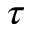<formula> <loc_0><loc_0><loc_500><loc_500>\tau</formula> 